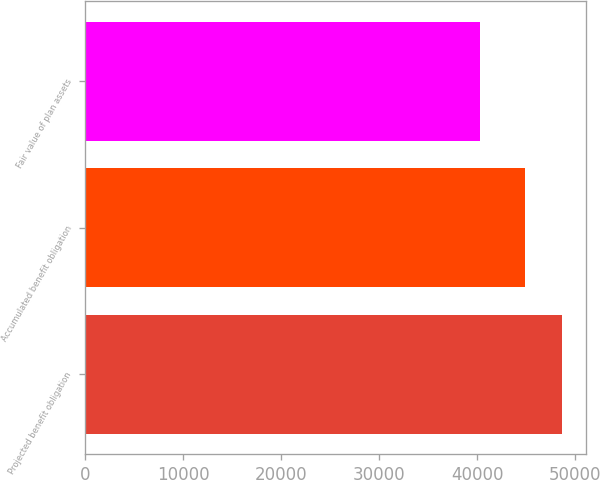Convert chart to OTSL. <chart><loc_0><loc_0><loc_500><loc_500><bar_chart><fcel>Projected benefit obligation<fcel>Accumulated benefit obligation<fcel>Fair value of plan assets<nl><fcel>48658<fcel>44863<fcel>40225<nl></chart> 